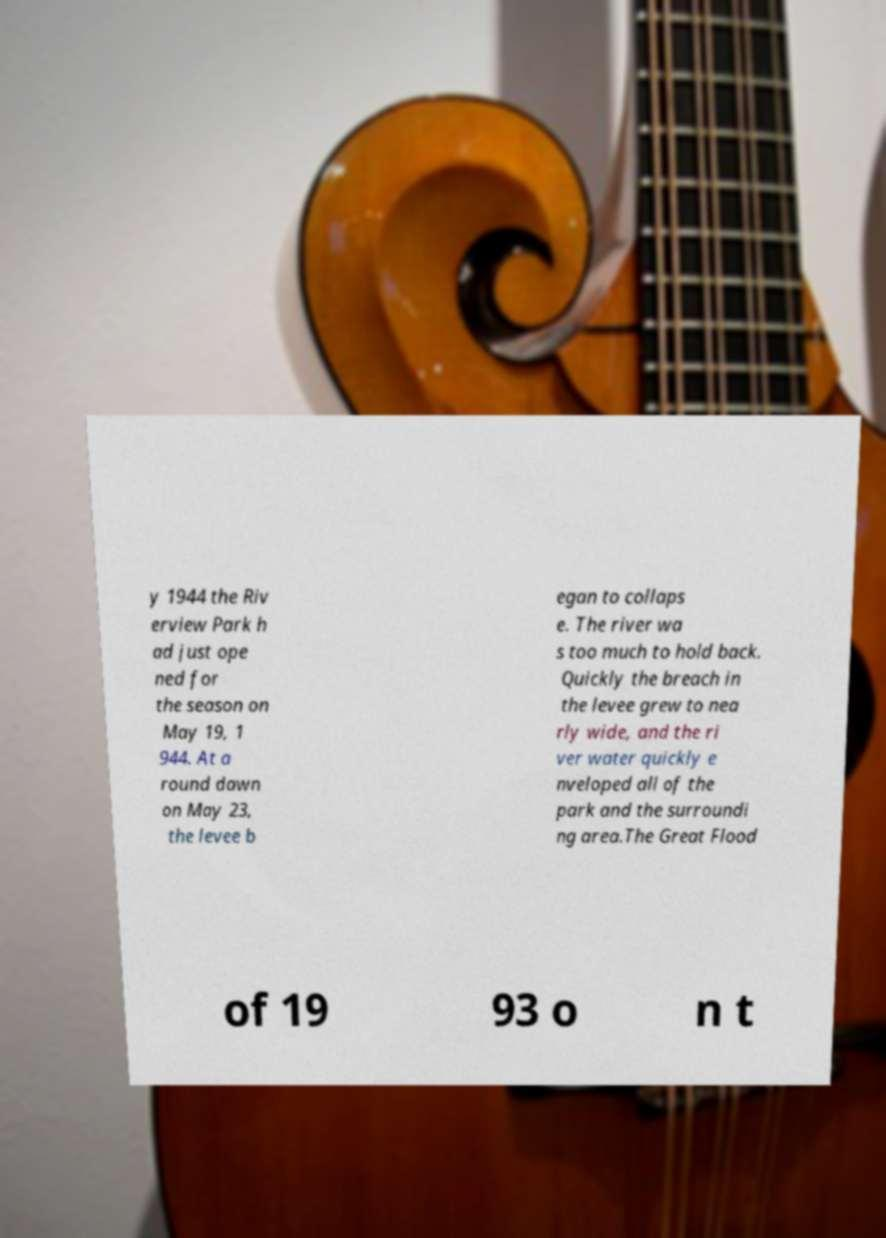I need the written content from this picture converted into text. Can you do that? y 1944 the Riv erview Park h ad just ope ned for the season on May 19, 1 944. At a round dawn on May 23, the levee b egan to collaps e. The river wa s too much to hold back. Quickly the breach in the levee grew to nea rly wide, and the ri ver water quickly e nveloped all of the park and the surroundi ng area.The Great Flood of 19 93 o n t 